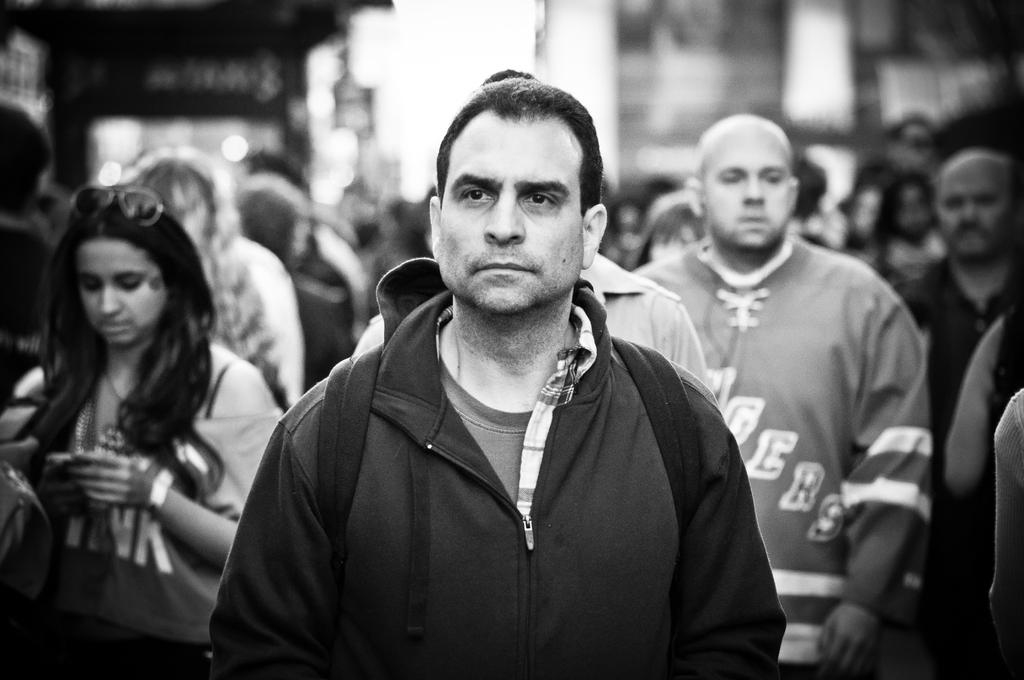How many people are present in the image? The number of people in the image cannot be determined from the provided fact. What news headlines are visible on the people's shirts in the image? There is no information about news headlines or shirts in the provided fact, so we cannot answer this question. 